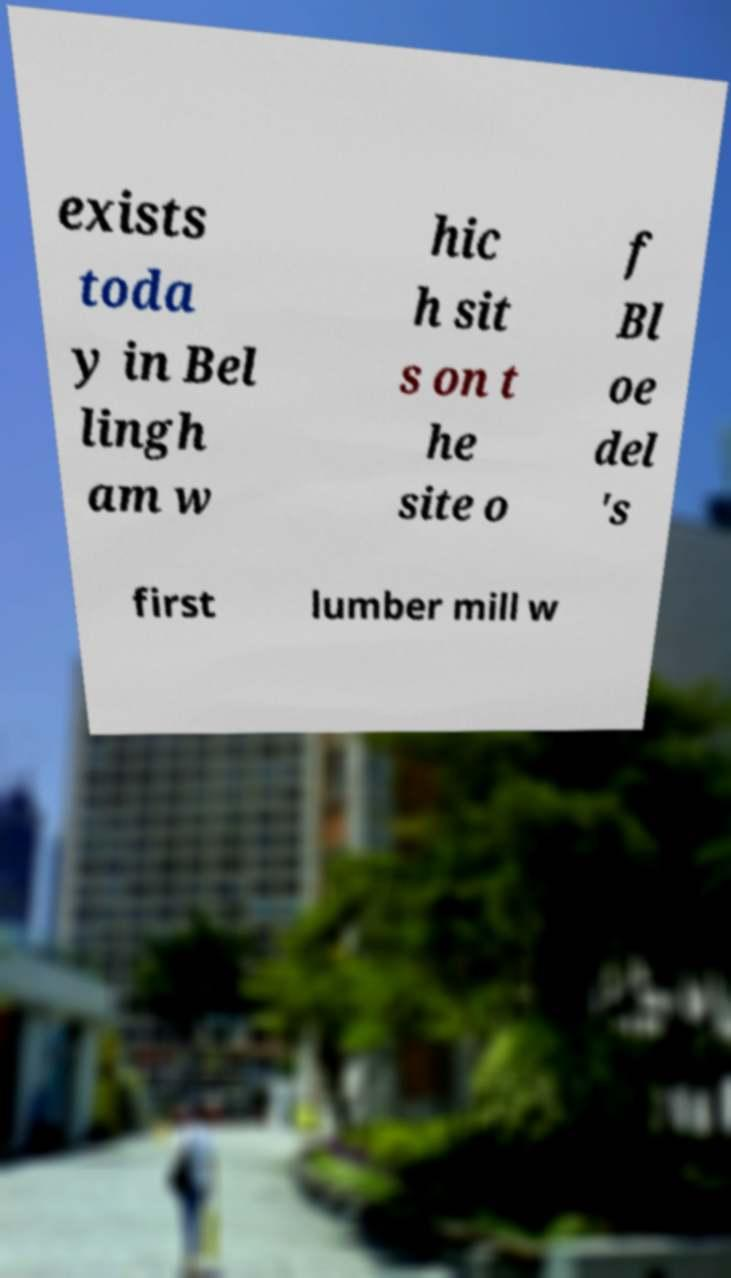Could you assist in decoding the text presented in this image and type it out clearly? exists toda y in Bel lingh am w hic h sit s on t he site o f Bl oe del 's first lumber mill w 